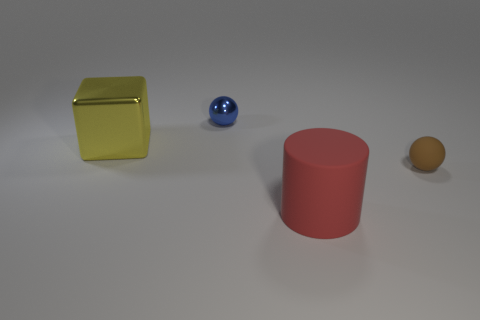What is the shape of the big object that is in front of the ball right of the sphere that is left of the big matte object?
Provide a short and direct response. Cylinder. What number of objects are big shiny cubes or spheres behind the small brown rubber thing?
Keep it short and to the point. 2. Does the thing behind the yellow object have the same size as the tiny brown matte ball?
Make the answer very short. Yes. What is the material of the tiny ball that is right of the big red rubber thing?
Give a very brief answer. Rubber. Is the number of big metal blocks in front of the blue object the same as the number of big rubber cylinders that are on the right side of the large yellow shiny thing?
Give a very brief answer. Yes. What is the color of the other thing that is the same shape as the small brown rubber thing?
Provide a succinct answer. Blue. Is there anything else that has the same color as the small metal object?
Your answer should be very brief. No. How many matte objects are cylinders or yellow cubes?
Offer a terse response. 1. Is the number of small brown things that are behind the red cylinder greater than the number of large green objects?
Keep it short and to the point. Yes. How many small things are either yellow things or cylinders?
Offer a very short reply. 0. 